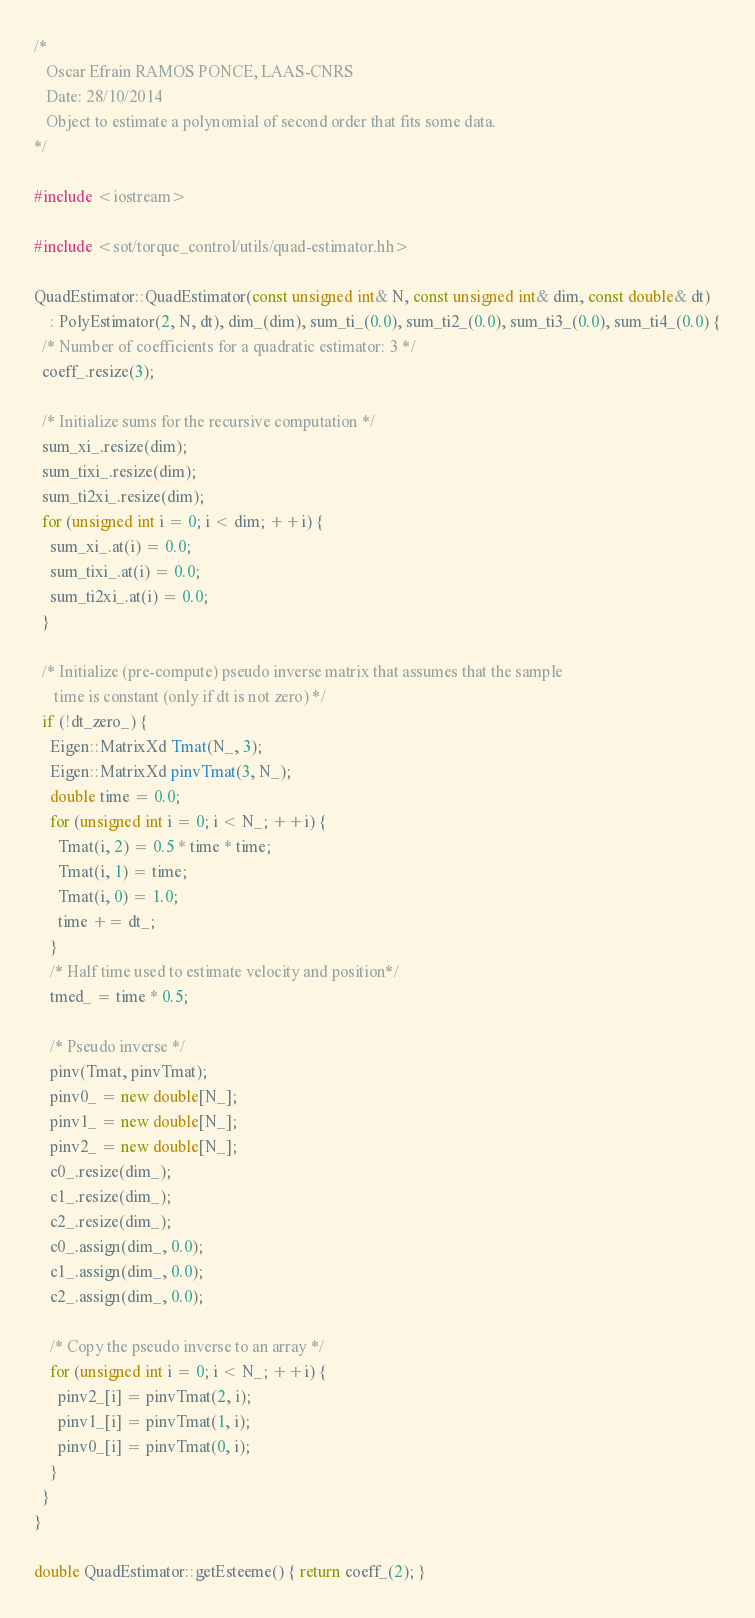Convert code to text. <code><loc_0><loc_0><loc_500><loc_500><_C++_>/*
   Oscar Efrain RAMOS PONCE, LAAS-CNRS
   Date: 28/10/2014
   Object to estimate a polynomial of second order that fits some data.
*/

#include <iostream>

#include <sot/torque_control/utils/quad-estimator.hh>

QuadEstimator::QuadEstimator(const unsigned int& N, const unsigned int& dim, const double& dt)
    : PolyEstimator(2, N, dt), dim_(dim), sum_ti_(0.0), sum_ti2_(0.0), sum_ti3_(0.0), sum_ti4_(0.0) {
  /* Number of coefficients for a quadratic estimator: 3 */
  coeff_.resize(3);

  /* Initialize sums for the recursive computation */
  sum_xi_.resize(dim);
  sum_tixi_.resize(dim);
  sum_ti2xi_.resize(dim);
  for (unsigned int i = 0; i < dim; ++i) {
    sum_xi_.at(i) = 0.0;
    sum_tixi_.at(i) = 0.0;
    sum_ti2xi_.at(i) = 0.0;
  }

  /* Initialize (pre-compute) pseudo inverse matrix that assumes that the sample
     time is constant (only if dt is not zero) */
  if (!dt_zero_) {
    Eigen::MatrixXd Tmat(N_, 3);
    Eigen::MatrixXd pinvTmat(3, N_);
    double time = 0.0;
    for (unsigned int i = 0; i < N_; ++i) {
      Tmat(i, 2) = 0.5 * time * time;
      Tmat(i, 1) = time;
      Tmat(i, 0) = 1.0;
      time += dt_;
    }
    /* Half time used to estimate velocity and position*/
    tmed_ = time * 0.5;

    /* Pseudo inverse */
    pinv(Tmat, pinvTmat);
    pinv0_ = new double[N_];
    pinv1_ = new double[N_];
    pinv2_ = new double[N_];
    c0_.resize(dim_);
    c1_.resize(dim_);
    c2_.resize(dim_);
    c0_.assign(dim_, 0.0);
    c1_.assign(dim_, 0.0);
    c2_.assign(dim_, 0.0);

    /* Copy the pseudo inverse to an array */
    for (unsigned int i = 0; i < N_; ++i) {
      pinv2_[i] = pinvTmat(2, i);
      pinv1_[i] = pinvTmat(1, i);
      pinv0_[i] = pinvTmat(0, i);
    }
  }
}

double QuadEstimator::getEsteeme() { return coeff_(2); }
</code> 